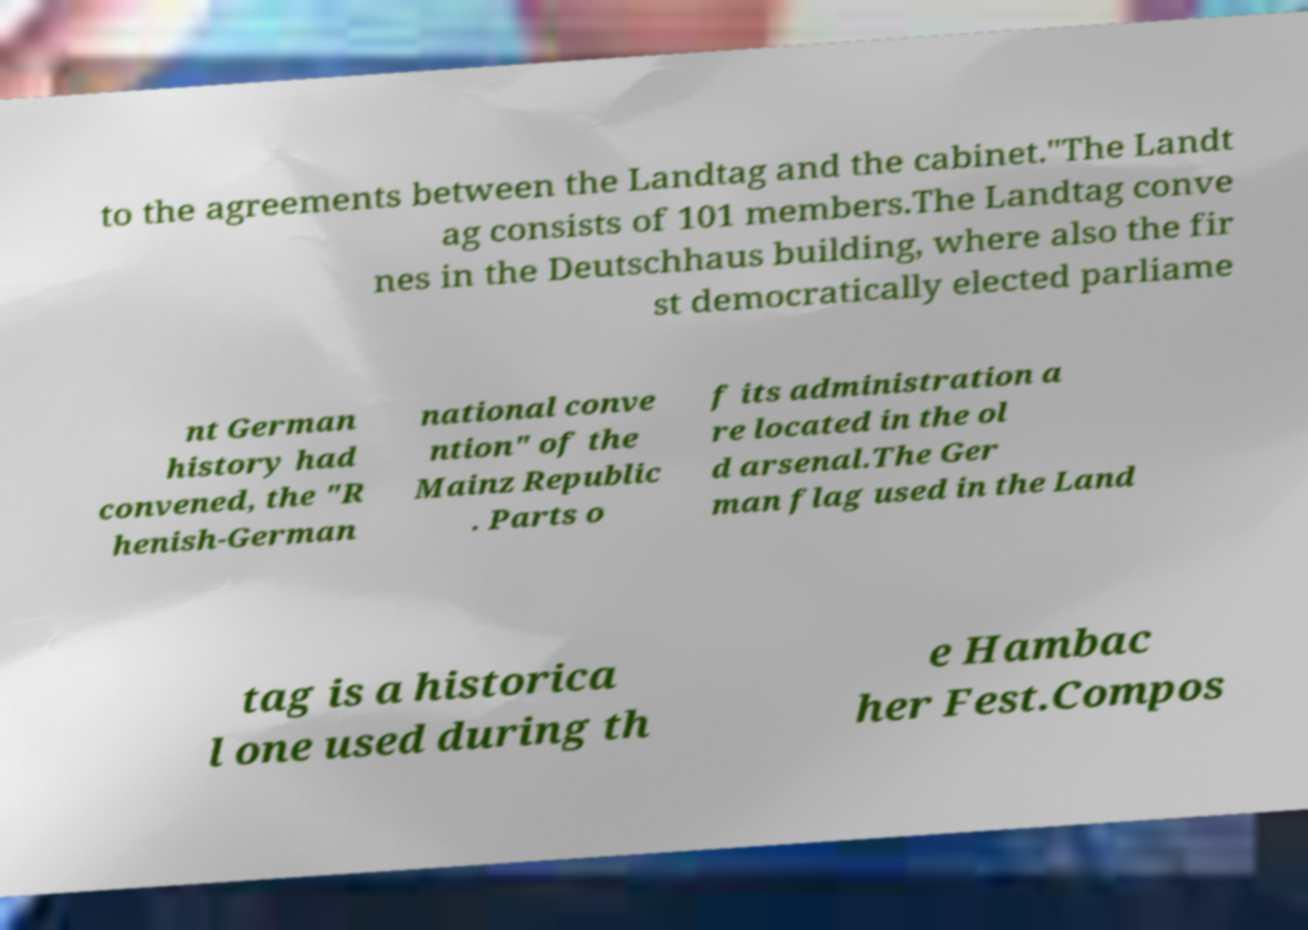For documentation purposes, I need the text within this image transcribed. Could you provide that? to the agreements between the Landtag and the cabinet."The Landt ag consists of 101 members.The Landtag conve nes in the Deutschhaus building, where also the fir st democratically elected parliame nt German history had convened, the "R henish-German national conve ntion" of the Mainz Republic . Parts o f its administration a re located in the ol d arsenal.The Ger man flag used in the Land tag is a historica l one used during th e Hambac her Fest.Compos 